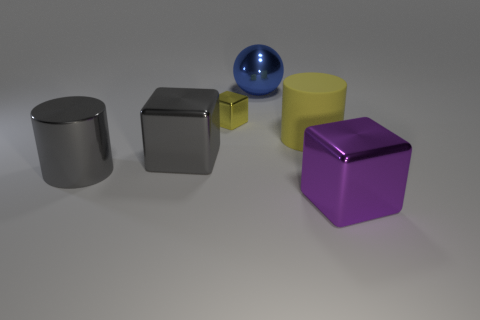Does the rubber object have the same color as the tiny object?
Provide a short and direct response. Yes. Is there another big yellow matte thing of the same shape as the yellow matte thing?
Give a very brief answer. No. There is a yellow object that is on the right side of the big blue ball; is its shape the same as the gray metallic thing in front of the large gray cube?
Offer a very short reply. Yes. What shape is the large thing that is both behind the large gray metal cylinder and to the right of the blue shiny thing?
Keep it short and to the point. Cylinder. Are there any gray things that have the same size as the metal sphere?
Keep it short and to the point. Yes. There is a rubber object; is it the same color as the block that is behind the big yellow rubber cylinder?
Keep it short and to the point. Yes. What is the tiny thing made of?
Provide a succinct answer. Metal. The big object in front of the gray metal cylinder is what color?
Give a very brief answer. Purple. How many matte cylinders have the same color as the big metallic sphere?
Your answer should be very brief. 0. What number of metallic objects are on the left side of the large yellow matte thing and to the right of the big yellow cylinder?
Your answer should be very brief. 0. 